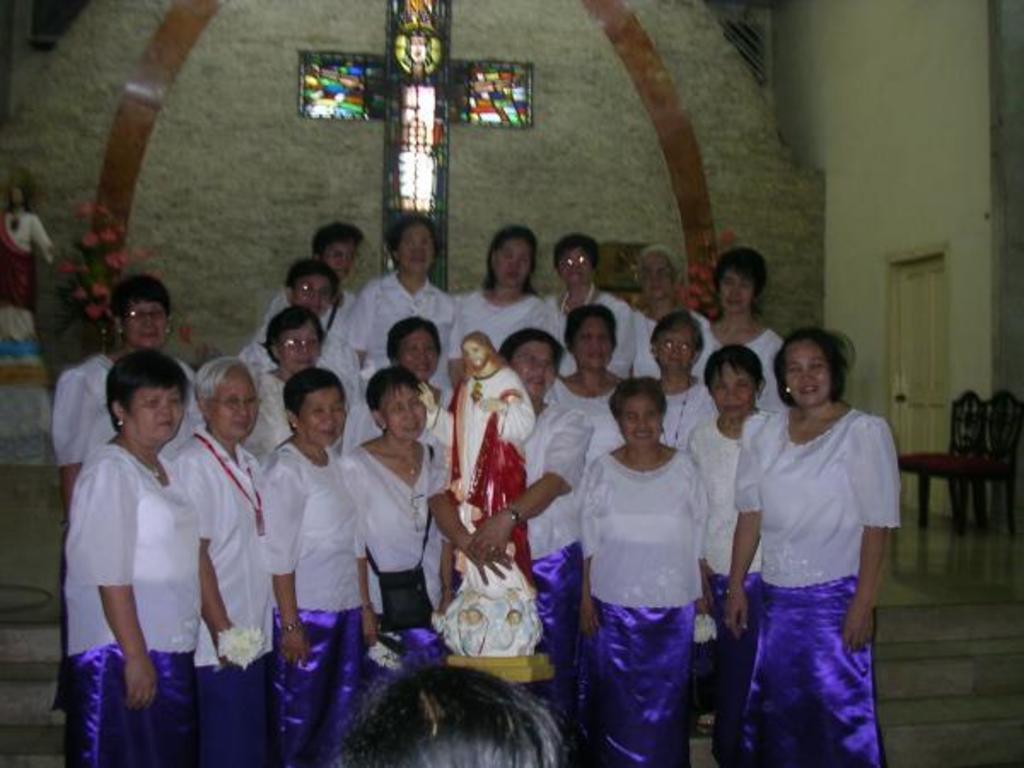Describe this image in one or two sentences. In this picture there are group of persons standing. In the center there is a statue. In the background there is a wall. In front of the wall there are flowers and there is a statue. On the right side of the wall there is a door and there are two chairs in front of the wall which is on the right side. 